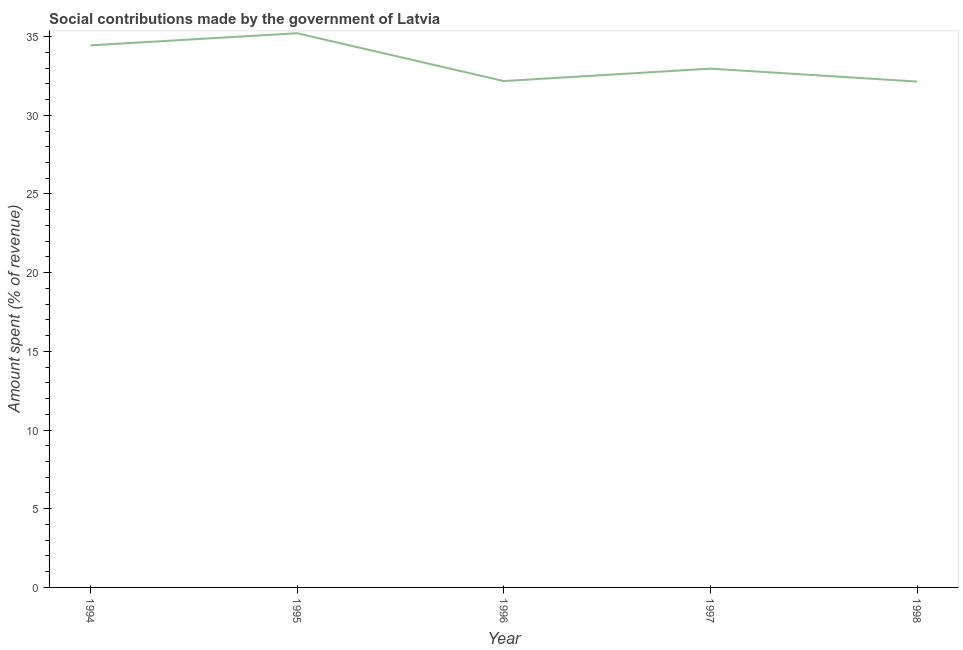What is the amount spent in making social contributions in 1996?
Make the answer very short. 32.17. Across all years, what is the maximum amount spent in making social contributions?
Your response must be concise. 35.21. Across all years, what is the minimum amount spent in making social contributions?
Keep it short and to the point. 32.14. In which year was the amount spent in making social contributions maximum?
Ensure brevity in your answer.  1995. In which year was the amount spent in making social contributions minimum?
Make the answer very short. 1998. What is the sum of the amount spent in making social contributions?
Provide a succinct answer. 166.93. What is the difference between the amount spent in making social contributions in 1995 and 1997?
Offer a terse response. 2.25. What is the average amount spent in making social contributions per year?
Your response must be concise. 33.39. What is the median amount spent in making social contributions?
Your answer should be compact. 32.96. What is the ratio of the amount spent in making social contributions in 1995 to that in 1997?
Give a very brief answer. 1.07. Is the amount spent in making social contributions in 1994 less than that in 1996?
Offer a terse response. No. Is the difference between the amount spent in making social contributions in 1995 and 1996 greater than the difference between any two years?
Keep it short and to the point. No. What is the difference between the highest and the second highest amount spent in making social contributions?
Offer a terse response. 0.77. What is the difference between the highest and the lowest amount spent in making social contributions?
Your answer should be very brief. 3.07. In how many years, is the amount spent in making social contributions greater than the average amount spent in making social contributions taken over all years?
Offer a terse response. 2. How many lines are there?
Your response must be concise. 1. What is the difference between two consecutive major ticks on the Y-axis?
Keep it short and to the point. 5. Are the values on the major ticks of Y-axis written in scientific E-notation?
Provide a short and direct response. No. Does the graph contain any zero values?
Your answer should be very brief. No. Does the graph contain grids?
Offer a terse response. No. What is the title of the graph?
Keep it short and to the point. Social contributions made by the government of Latvia. What is the label or title of the Y-axis?
Provide a succinct answer. Amount spent (% of revenue). What is the Amount spent (% of revenue) in 1994?
Your answer should be very brief. 34.44. What is the Amount spent (% of revenue) of 1995?
Keep it short and to the point. 35.21. What is the Amount spent (% of revenue) in 1996?
Your answer should be very brief. 32.17. What is the Amount spent (% of revenue) of 1997?
Offer a very short reply. 32.96. What is the Amount spent (% of revenue) of 1998?
Keep it short and to the point. 32.14. What is the difference between the Amount spent (% of revenue) in 1994 and 1995?
Ensure brevity in your answer.  -0.77. What is the difference between the Amount spent (% of revenue) in 1994 and 1996?
Offer a very short reply. 2.27. What is the difference between the Amount spent (% of revenue) in 1994 and 1997?
Ensure brevity in your answer.  1.48. What is the difference between the Amount spent (% of revenue) in 1994 and 1998?
Your answer should be compact. 2.3. What is the difference between the Amount spent (% of revenue) in 1995 and 1996?
Ensure brevity in your answer.  3.04. What is the difference between the Amount spent (% of revenue) in 1995 and 1997?
Ensure brevity in your answer.  2.25. What is the difference between the Amount spent (% of revenue) in 1995 and 1998?
Offer a terse response. 3.07. What is the difference between the Amount spent (% of revenue) in 1996 and 1997?
Keep it short and to the point. -0.79. What is the difference between the Amount spent (% of revenue) in 1996 and 1998?
Offer a very short reply. 0.03. What is the difference between the Amount spent (% of revenue) in 1997 and 1998?
Offer a terse response. 0.82. What is the ratio of the Amount spent (% of revenue) in 1994 to that in 1996?
Provide a short and direct response. 1.07. What is the ratio of the Amount spent (% of revenue) in 1994 to that in 1997?
Your response must be concise. 1.04. What is the ratio of the Amount spent (% of revenue) in 1994 to that in 1998?
Provide a short and direct response. 1.07. What is the ratio of the Amount spent (% of revenue) in 1995 to that in 1996?
Give a very brief answer. 1.09. What is the ratio of the Amount spent (% of revenue) in 1995 to that in 1997?
Keep it short and to the point. 1.07. What is the ratio of the Amount spent (% of revenue) in 1995 to that in 1998?
Offer a very short reply. 1.1. What is the ratio of the Amount spent (% of revenue) in 1996 to that in 1997?
Provide a short and direct response. 0.98. What is the ratio of the Amount spent (% of revenue) in 1996 to that in 1998?
Offer a terse response. 1. What is the ratio of the Amount spent (% of revenue) in 1997 to that in 1998?
Your answer should be compact. 1.03. 